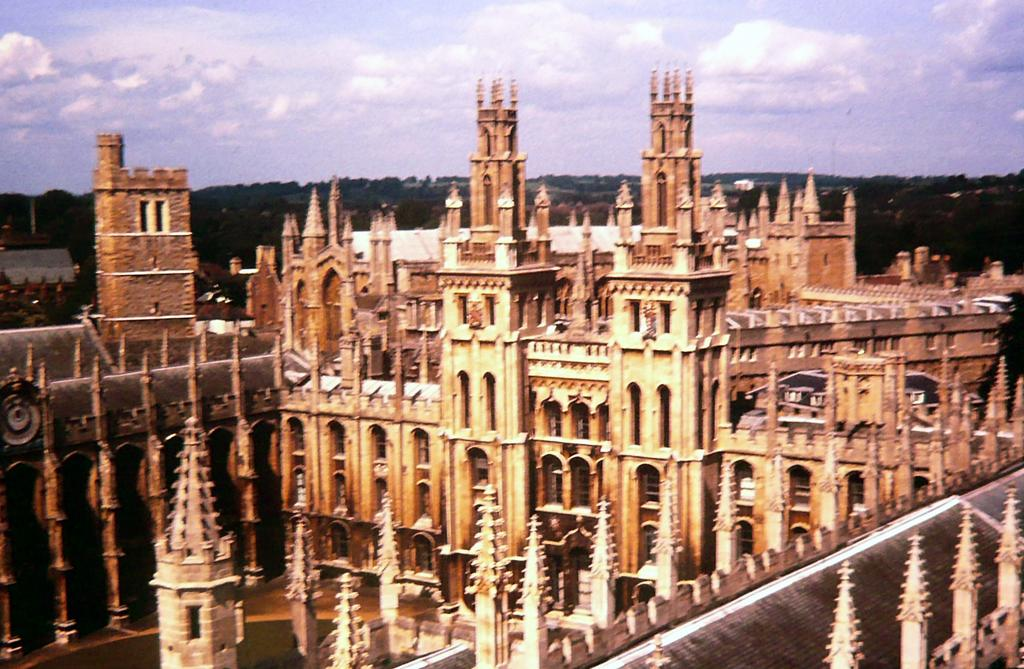What type of structure is shown in the image? The image appears to depict a castle. What specific features can be seen on the castle? The castle has spires. What can be seen in the background of the image? There are trees in the background of the image. What is visible in the sky in the image? Clouds are visible in the sky. What type of stick can be seen in the image? There is no stick present in the image. Can you describe the animal that is sitting on the castle's spire? There is no animal present in the image; it only depicts the castle and its surroundings. 